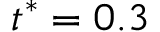Convert formula to latex. <formula><loc_0><loc_0><loc_500><loc_500>t ^ { * } = 0 . 3</formula> 